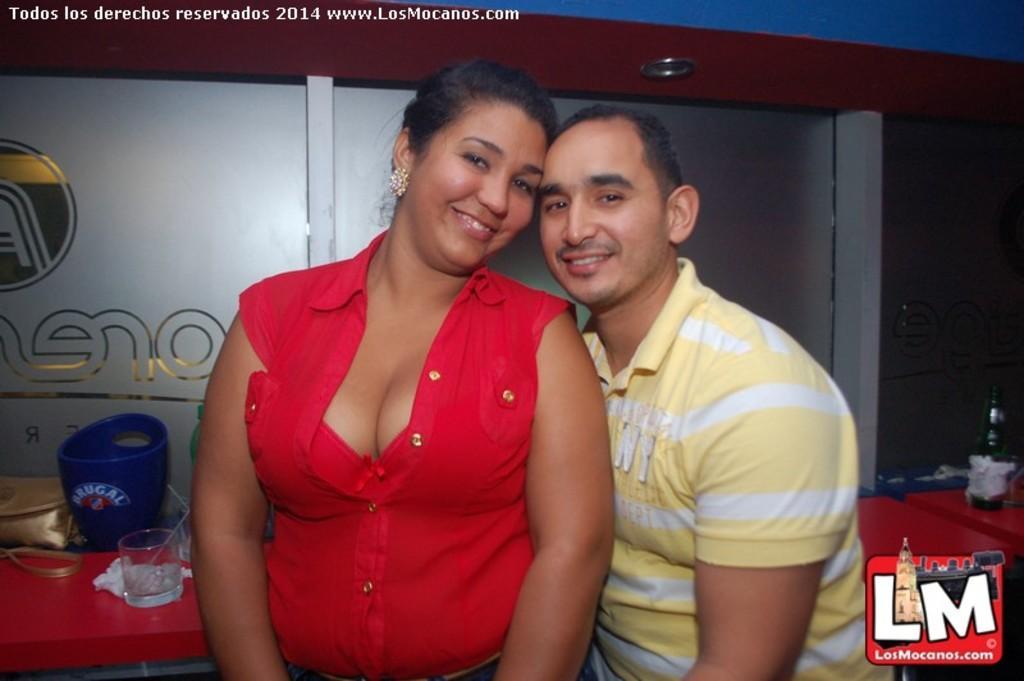Please provide a concise description of this image. In this image there is one woman standing on the left side of this image and there is one person standing on the right side of this image, and there is a logo in the bottom right corner of this image, and there is a wall in the background. There are some objects on the bottom left side of this image and there is a bottle on the right side of this image. 